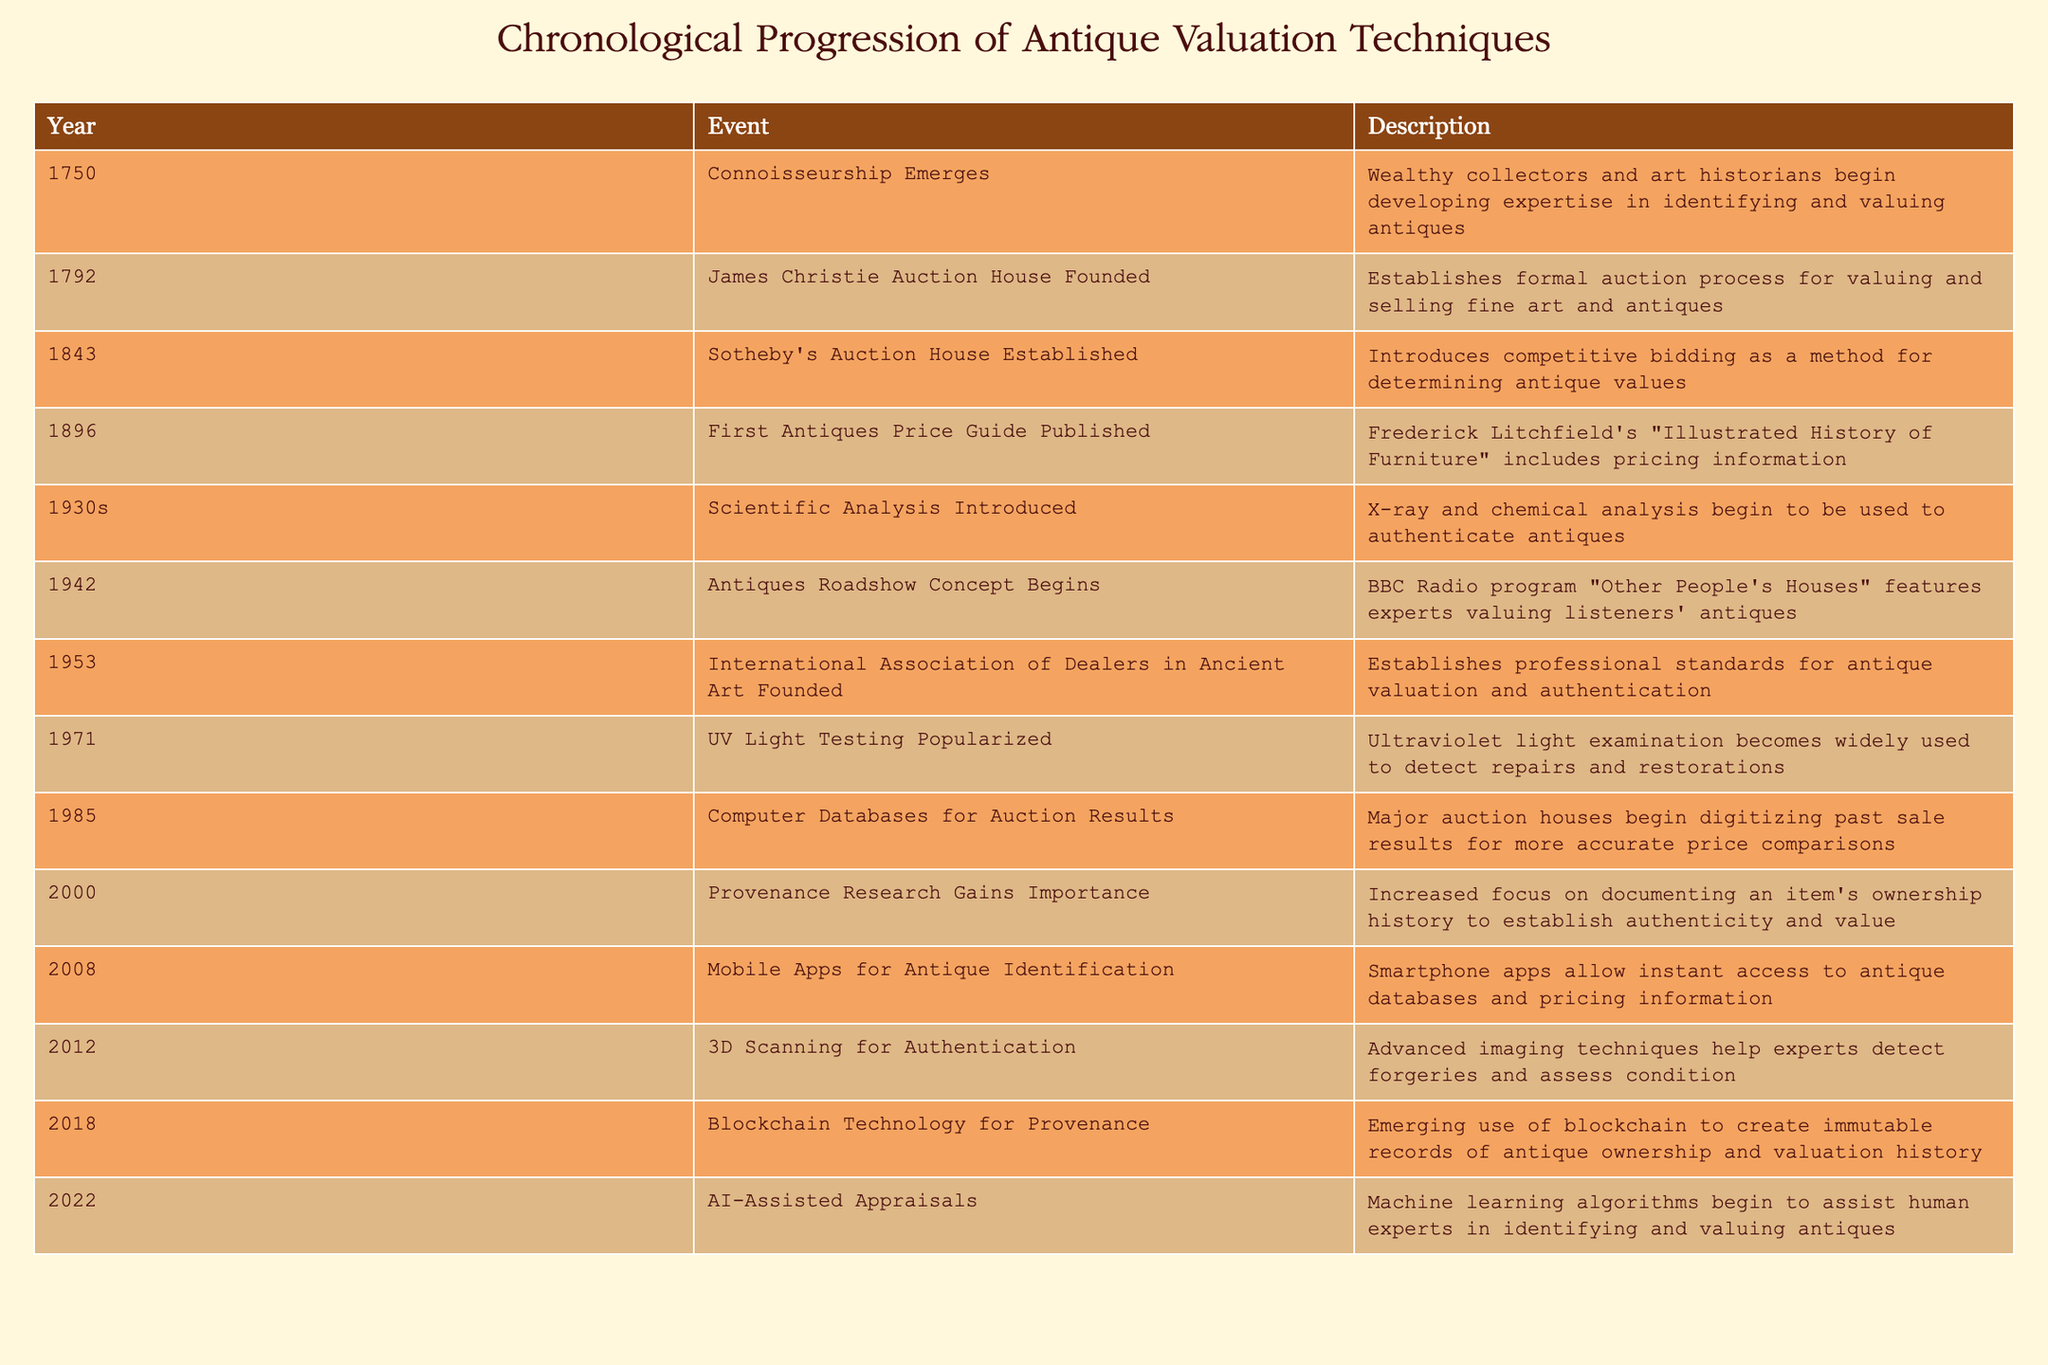What year did James Christie auction house get founded? The table shows that James Christie Auction House was founded in the year 1792. This is a direct retrieval from the 'Year' column corresponding to the event 'James Christie Auction House Founded'.
Answer: 1792 Which technique was introduced in the 1930s that enhanced antique valuation? According to the table, the 1930s saw the introduction of scientific analysis, including X-ray and chemical analysis, which enhanced the ability to authenticate antiques.
Answer: Scientific analysis How many years passed between the establishment of Sotheby’s Auction House and the publication of the first antiques price guide? Sotheby’s Auction House was established in 1843, and the first antiques price guide was published in 1896. The difference is 1896 - 1843 = 53 years. Therefore, 53 years passed between these events.
Answer: 53 Was the concept of Antiques Roadshow initiated before or after the establishment of the International Association of Dealers in Ancient Art? The Antiques Roadshow concept began in 1942, and the International Association of Dealers in Ancient Art was founded in 1953. Since 1942 is before 1953, the answer is before.
Answer: Before In what year did AI-assisted appraisals start to emerge as a technique for valuing antiques? From the table, we can see that AI-assisted appraisals emerged in 2022. This is directly taken from the 'Year' column under the relevant event description.
Answer: 2022 What is the average year the valuation techniques and methodologies were introduced in the 20th century (from 1900 to 1999)? We identify the years within the 20th century: 1930s (let's approximate as 1935), 1942, 1953, 1971, 1985. Adding these gives: 1935 + 1942 + 1953 + 1971 + 1985 = 9756. There are 5 values, so average = 9756/5 = 1951.2, or approximately 1951 if we round down.
Answer: 1951 Did the introduction of mobile apps for antique identification occur before the use of 3D scanning for authentication? The table indicates that mobile apps for antique identification were introduced in 2008, while 3D scanning for authentication was introduced in 2012. Since 2008 is before 2012, the answer to this question is yes.
Answer: Yes Which technique saw a major paradigm shift due to the advent of blockchain technology, and what year was that? The table indicates that blockchain technology started being used for provenance in 2018, suggesting a paradigm shift in how ownership and valuation history is recorded. The specific technique that it impacted is provenance research.
Answer: Provenance research, 2018 How many techniques were introduced after the year 2000? From the table, the techniques introduced after 2000 are Provenance Research (2000), Mobile Apps (2008), 3D Scanning (2012), Blockchain (2018), and AI-Assisted Appraisals (2022). This totals to 5 techniques after 2000.
Answer: 5 